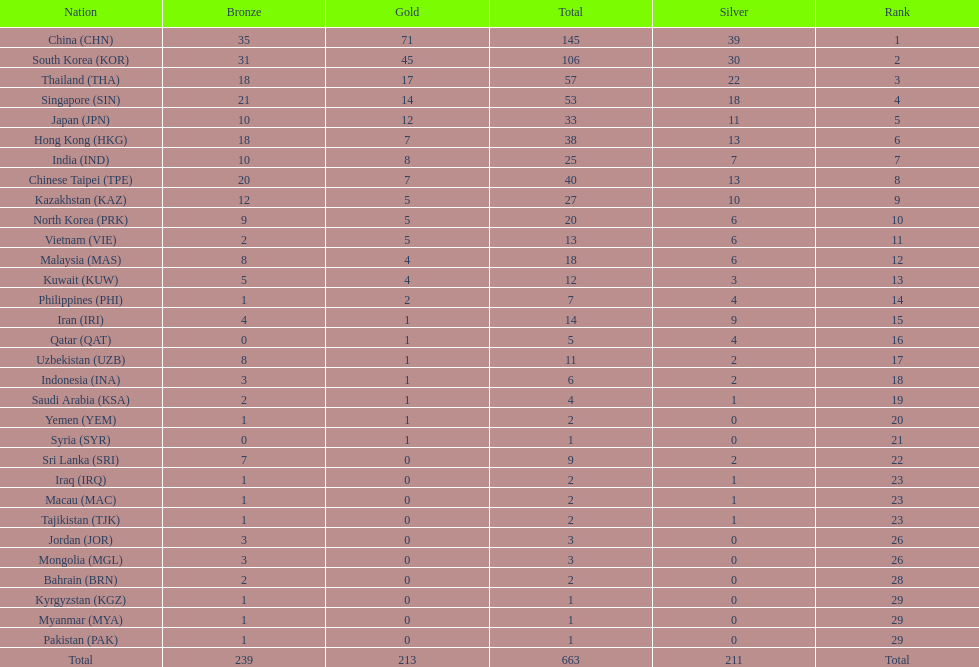How many countries have at least 10 gold medals in the asian youth games? 5. 